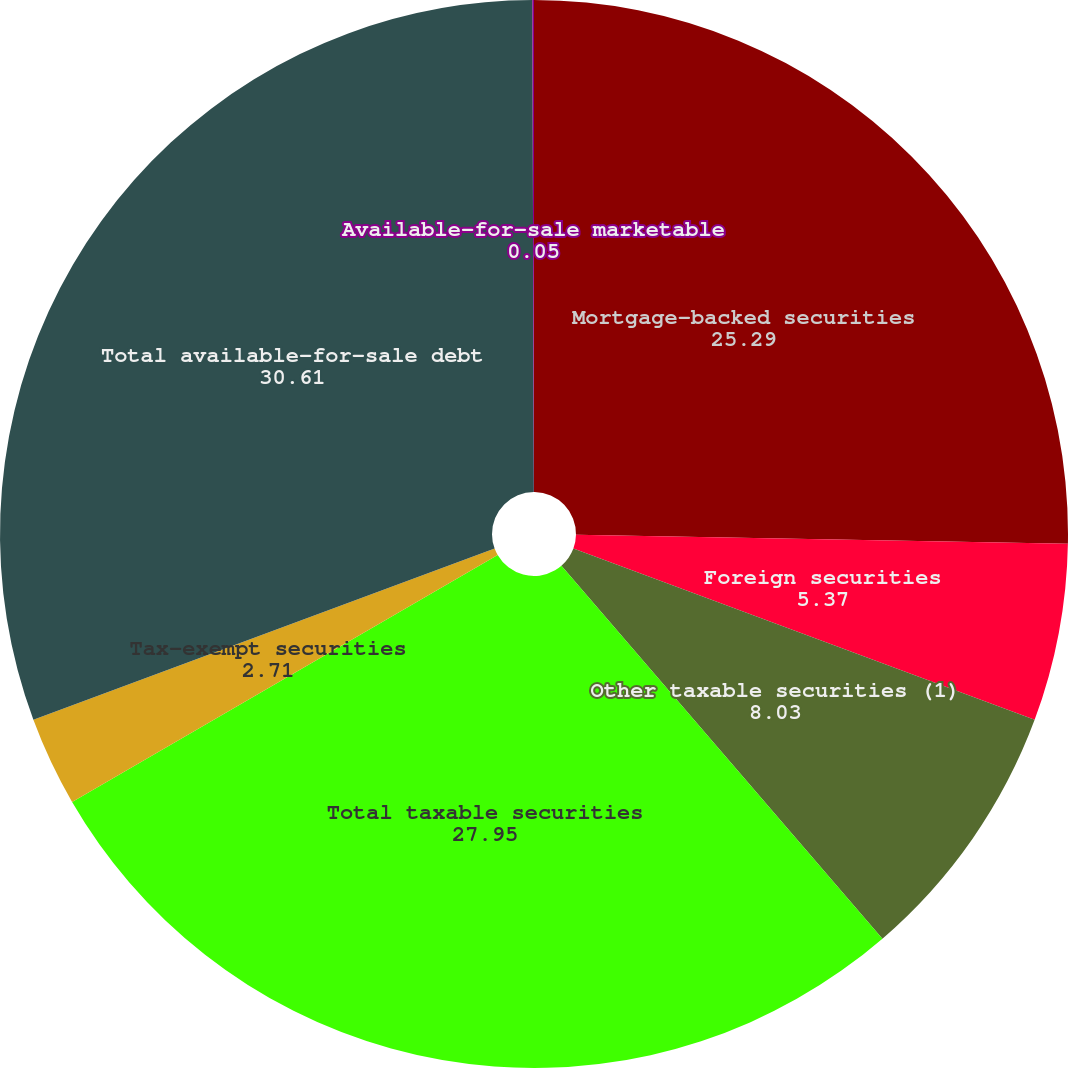Convert chart to OTSL. <chart><loc_0><loc_0><loc_500><loc_500><pie_chart><fcel>Mortgage-backed securities<fcel>Foreign securities<fcel>Other taxable securities (1)<fcel>Total taxable securities<fcel>Tax-exempt securities<fcel>Total available-for-sale debt<fcel>Available-for-sale marketable<nl><fcel>25.29%<fcel>5.37%<fcel>8.03%<fcel>27.95%<fcel>2.71%<fcel>30.61%<fcel>0.05%<nl></chart> 